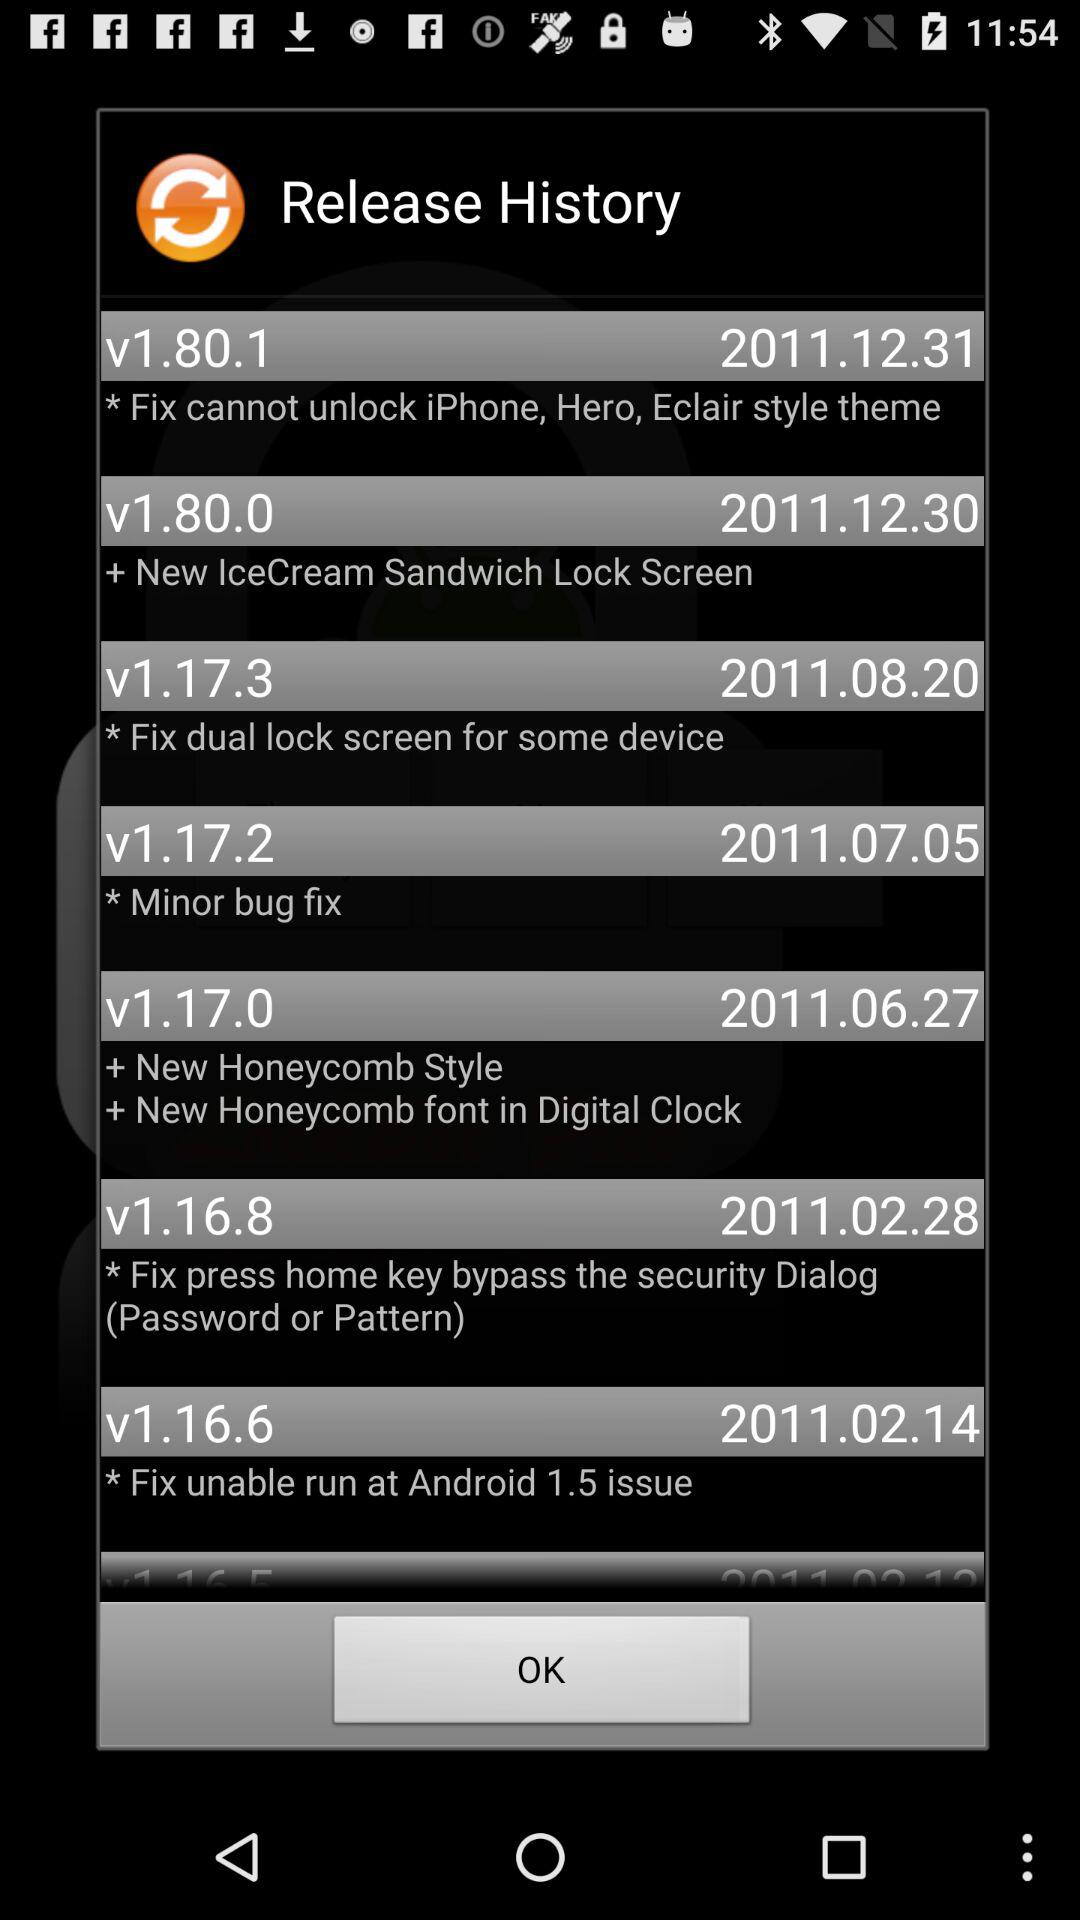When was the version number v1.16.8 released? The version number v1.16.8 was released on February 28, 2011. 